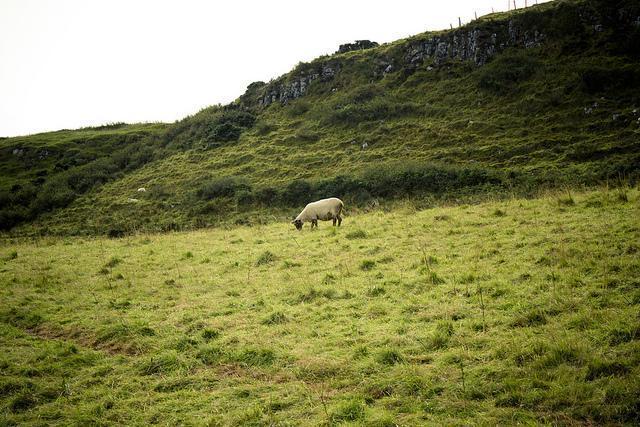How many sheep are in the picture?
Give a very brief answer. 1. How many animals?
Give a very brief answer. 1. How many sheep are on the hillside?
Give a very brief answer. 1. 